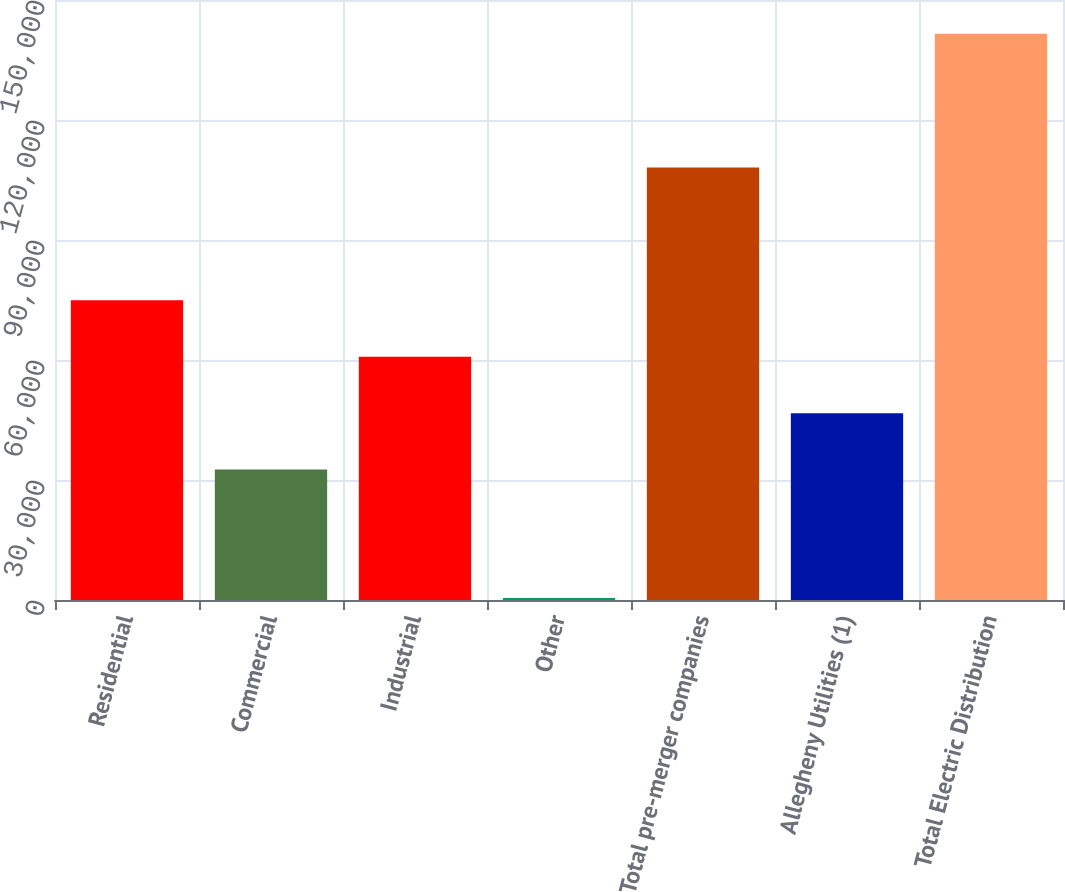Convert chart to OTSL. <chart><loc_0><loc_0><loc_500><loc_500><bar_chart><fcel>Residential<fcel>Commercial<fcel>Industrial<fcel>Other<fcel>Total pre-merger companies<fcel>Allegheny Utilities (1)<fcel>Total Electric Distribution<nl><fcel>74929.5<fcel>32610<fcel>60823<fcel>513<fcel>108129<fcel>46716.5<fcel>141578<nl></chart> 